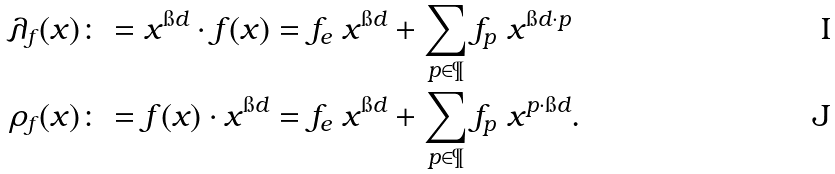<formula> <loc_0><loc_0><loc_500><loc_500>\lambda _ { f } ( x ) & \colon = x ^ { \i d } \cdot f ( x ) = f _ { e } \ x ^ { \i d } + \sum _ { p \in \P } f _ { p } \ x ^ { \i d \cdot p } \\ \rho _ { f } ( x ) & \colon = f ( x ) \cdot x ^ { \i d } = f _ { e } \ x ^ { \i d } + \sum _ { p \in \P } f _ { p } \ x ^ { p \cdot \i d } .</formula> 